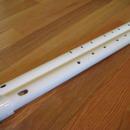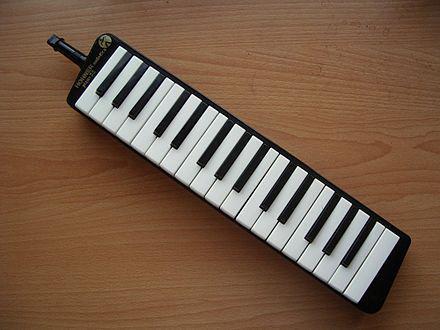The first image is the image on the left, the second image is the image on the right. Analyze the images presented: Is the assertion "The left image shows a white PVC-look tube with a cut part and a metal-bladed tool near it." valid? Answer yes or no. No. The first image is the image on the left, the second image is the image on the right. Assess this claim about the two images: "A sharp object sits near a pipe in the image on the left.". Correct or not? Answer yes or no. No. 